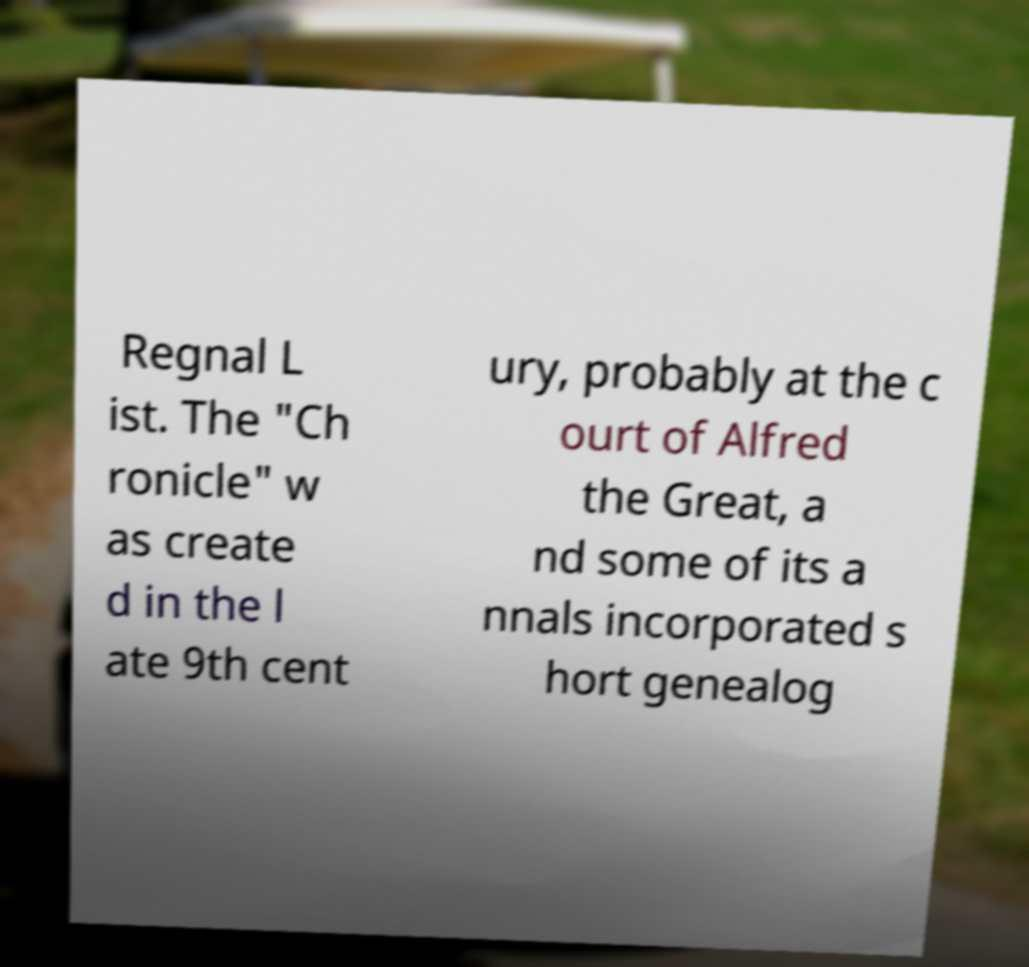There's text embedded in this image that I need extracted. Can you transcribe it verbatim? Regnal L ist. The "Ch ronicle" w as create d in the l ate 9th cent ury, probably at the c ourt of Alfred the Great, a nd some of its a nnals incorporated s hort genealog 